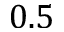<formula> <loc_0><loc_0><loc_500><loc_500>0 . 5</formula> 